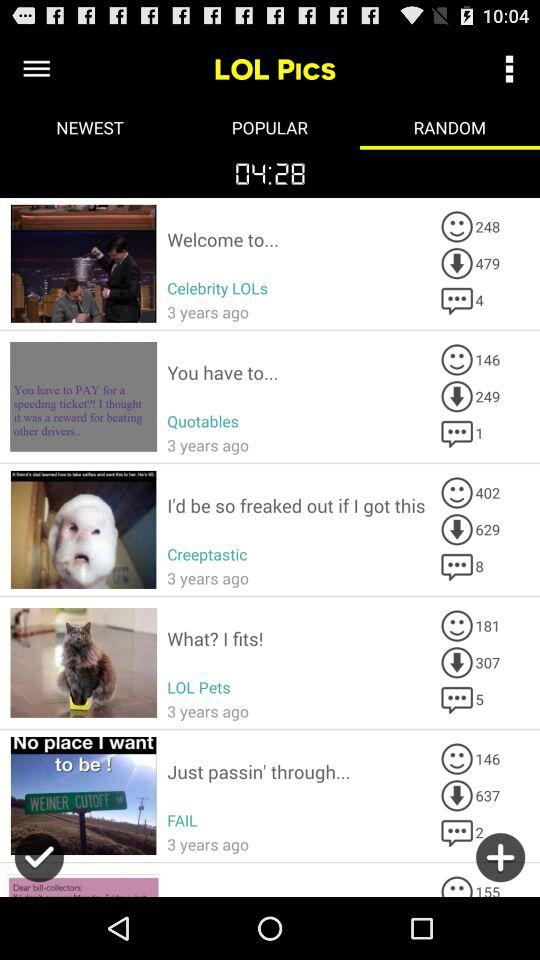How many people have download the picture posted by "Quotables"? The number of people who have downloaded the picture posted by "Quotables" is 249. 